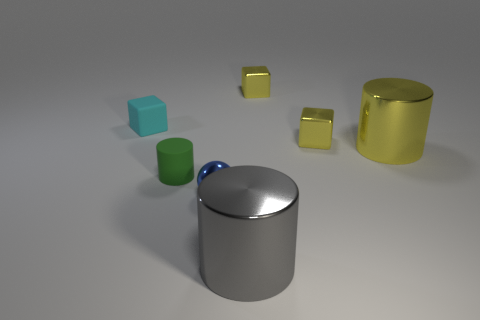Subtract all yellow metallic cylinders. How many cylinders are left? 2 Subtract all gray cylinders. How many yellow cubes are left? 2 Add 2 yellow metal blocks. How many objects exist? 9 Subtract 1 cubes. How many cubes are left? 2 Subtract all balls. How many objects are left? 6 Subtract all blue cubes. Subtract all blue cylinders. How many cubes are left? 3 Add 2 small yellow shiny cubes. How many small yellow shiny cubes are left? 4 Add 3 green matte cylinders. How many green matte cylinders exist? 4 Subtract 0 red balls. How many objects are left? 7 Subtract all large blocks. Subtract all cylinders. How many objects are left? 4 